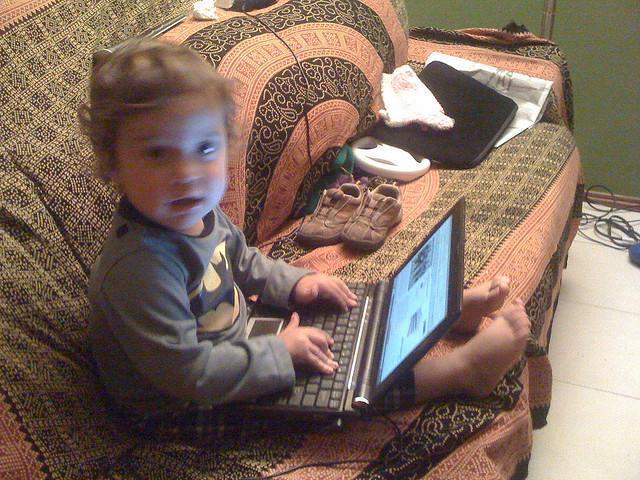How many couches are in the photo?
Give a very brief answer. 1. 